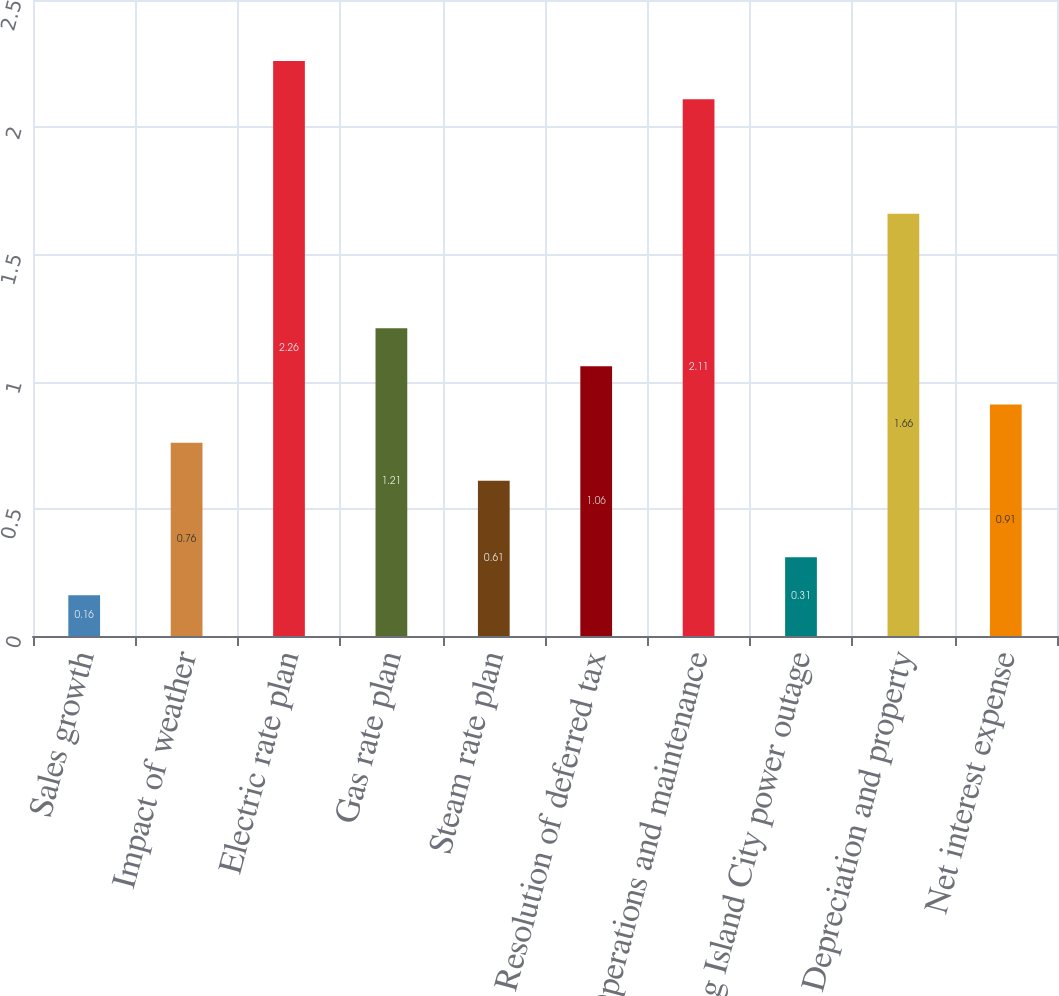Convert chart to OTSL. <chart><loc_0><loc_0><loc_500><loc_500><bar_chart><fcel>Sales growth<fcel>Impact of weather<fcel>Electric rate plan<fcel>Gas rate plan<fcel>Steam rate plan<fcel>Resolution of deferred tax<fcel>Operations and maintenance<fcel>Long Island City power outage<fcel>Depreciation and property<fcel>Net interest expense<nl><fcel>0.16<fcel>0.76<fcel>2.26<fcel>1.21<fcel>0.61<fcel>1.06<fcel>2.11<fcel>0.31<fcel>1.66<fcel>0.91<nl></chart> 